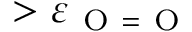Convert formula to latex. <formula><loc_0><loc_0><loc_500><loc_500>> \varepsilon _ { O = O }</formula> 